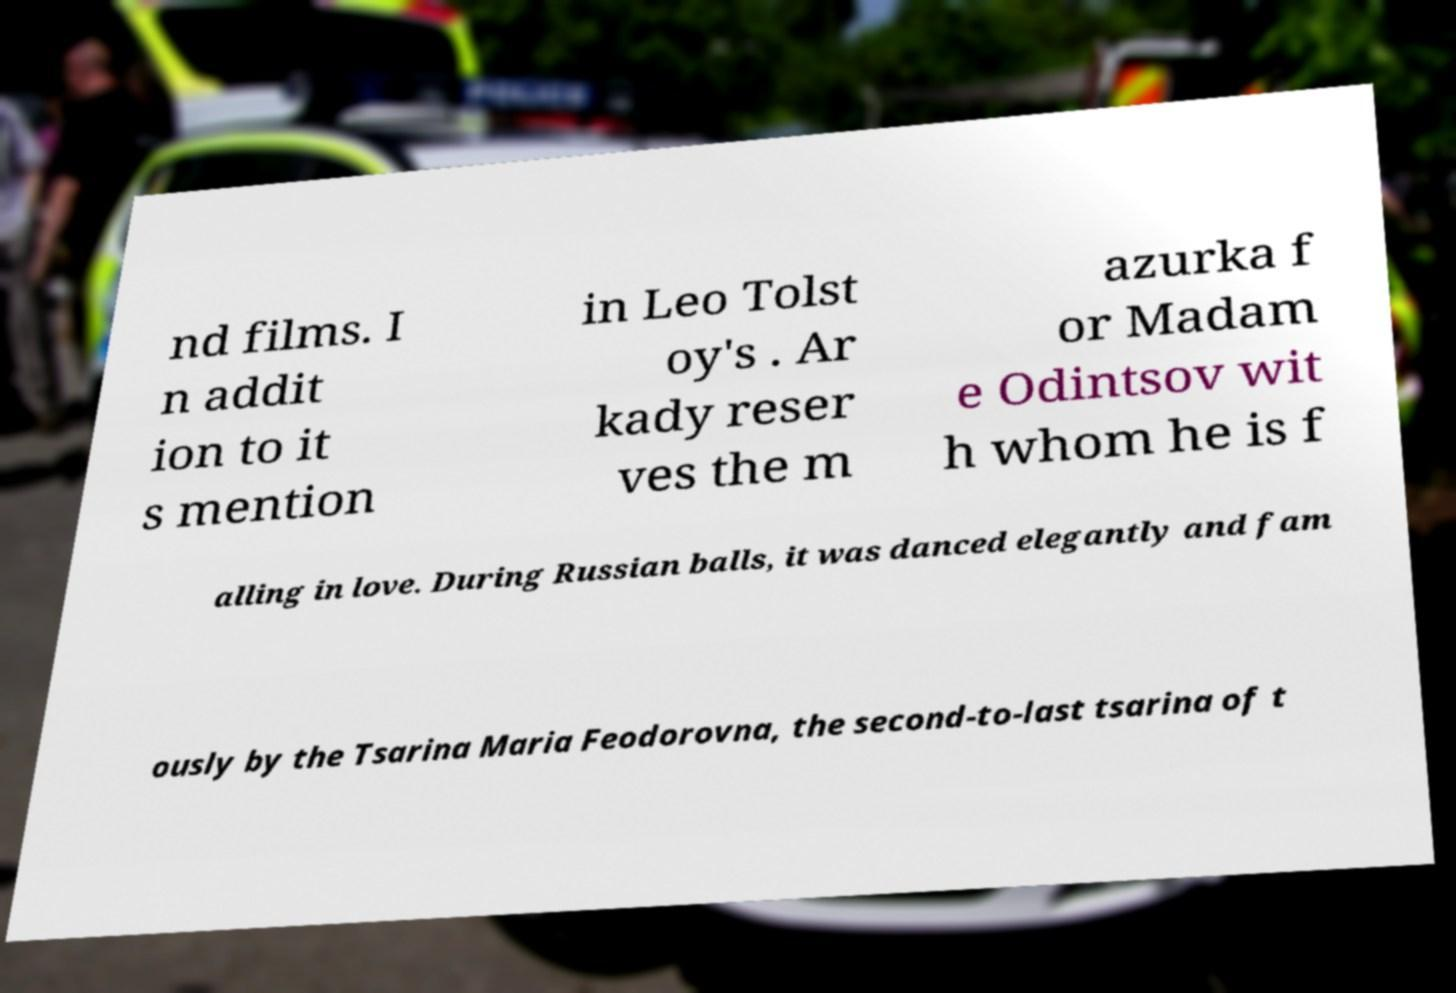Can you accurately transcribe the text from the provided image for me? nd films. I n addit ion to it s mention in Leo Tolst oy's . Ar kady reser ves the m azurka f or Madam e Odintsov wit h whom he is f alling in love. During Russian balls, it was danced elegantly and fam ously by the Tsarina Maria Feodorovna, the second-to-last tsarina of t 